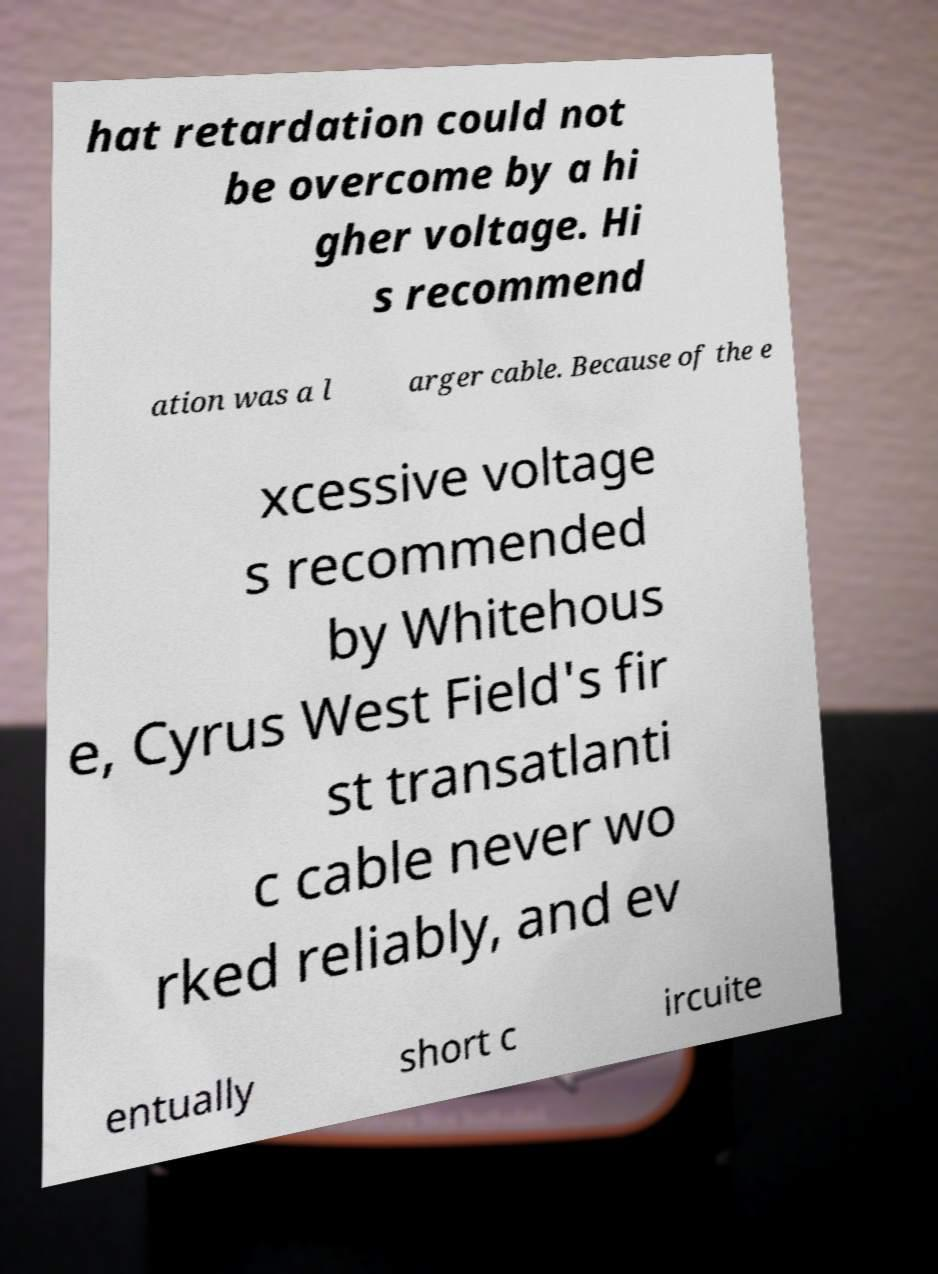Please identify and transcribe the text found in this image. hat retardation could not be overcome by a hi gher voltage. Hi s recommend ation was a l arger cable. Because of the e xcessive voltage s recommended by Whitehous e, Cyrus West Field's fir st transatlanti c cable never wo rked reliably, and ev entually short c ircuite 